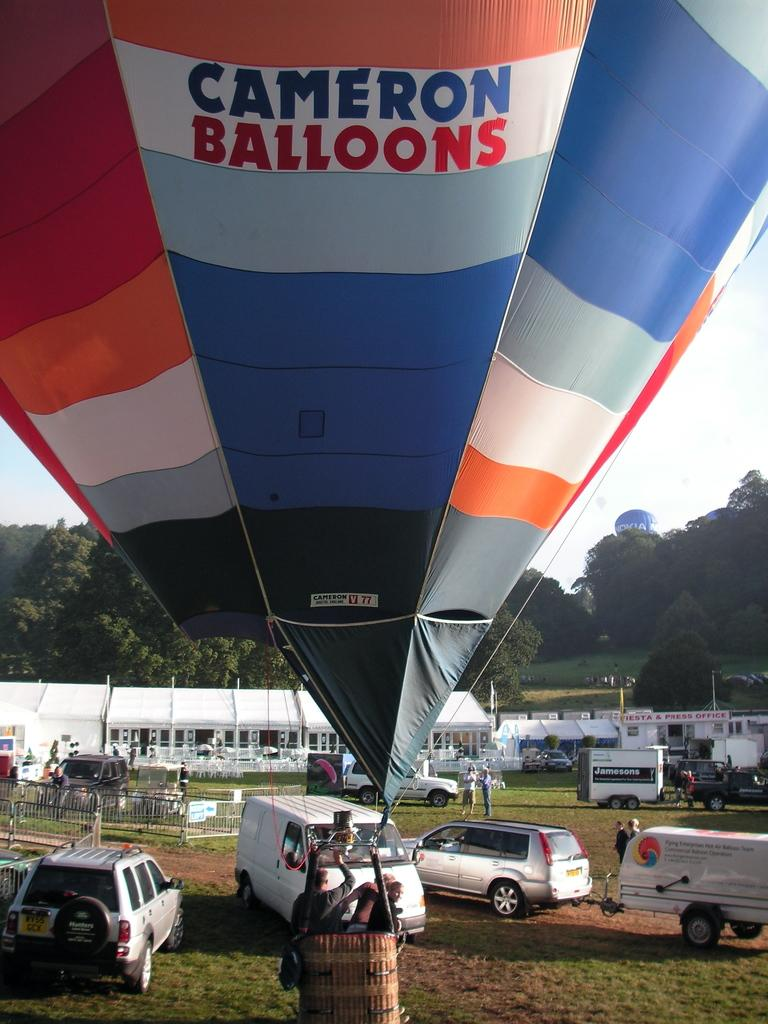<image>
Summarize the visual content of the image. A Cameron Balloons hot air balloon in a field 